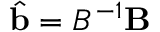<formula> <loc_0><loc_0><loc_500><loc_500>\hat { b } = B ^ { - 1 } B</formula> 